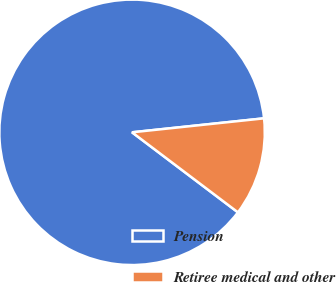Convert chart to OTSL. <chart><loc_0><loc_0><loc_500><loc_500><pie_chart><fcel>Pension<fcel>Retiree medical and other<nl><fcel>88.02%<fcel>11.98%<nl></chart> 